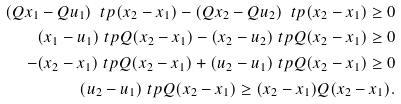Convert formula to latex. <formula><loc_0><loc_0><loc_500><loc_500>( Q x _ { 1 } - Q u _ { 1 } ) ^ { \ } t p ( x _ { 2 } - x _ { 1 } ) - ( Q x _ { 2 } - Q u _ { 2 } ) ^ { \ } t p ( x _ { 2 } - x _ { 1 } ) \geq 0 \\ ( x _ { 1 } - u _ { 1 } ) ^ { \ } t p Q ( x _ { 2 } - x _ { 1 } ) - ( x _ { 2 } - u _ { 2 } ) ^ { \ } t p Q ( x _ { 2 } - x _ { 1 } ) \geq 0 \\ - ( x _ { 2 } - x _ { 1 } ) ^ { \ } t p Q ( x _ { 2 } - x _ { 1 } ) + ( u _ { 2 } - u _ { 1 } ) ^ { \ } t p Q ( x _ { 2 } - x _ { 1 } ) \geq 0 \\ ( u _ { 2 } - u _ { 1 } ) ^ { \ } t p Q ( x _ { 2 } - x _ { 1 } ) \geq ( x _ { 2 } - x _ { 1 } ) Q ( x _ { 2 } - x _ { 1 } ) .</formula> 